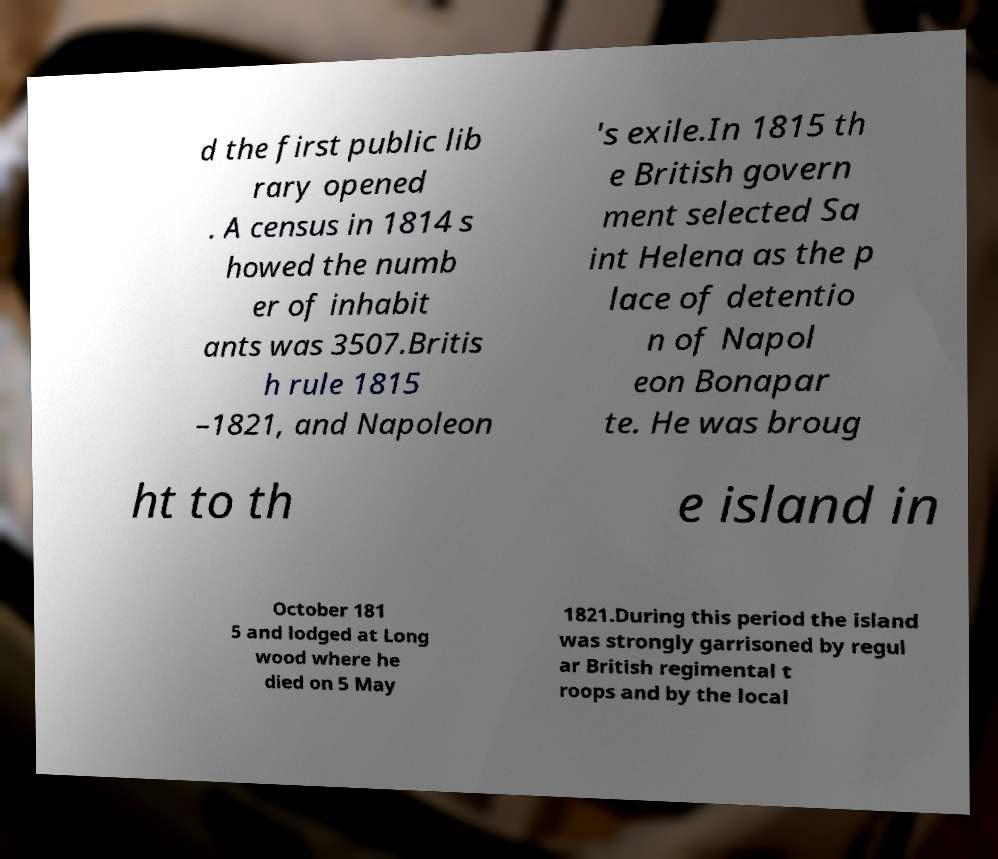Can you accurately transcribe the text from the provided image for me? d the first public lib rary opened . A census in 1814 s howed the numb er of inhabit ants was 3507.Britis h rule 1815 –1821, and Napoleon 's exile.In 1815 th e British govern ment selected Sa int Helena as the p lace of detentio n of Napol eon Bonapar te. He was broug ht to th e island in October 181 5 and lodged at Long wood where he died on 5 May 1821.During this period the island was strongly garrisoned by regul ar British regimental t roops and by the local 